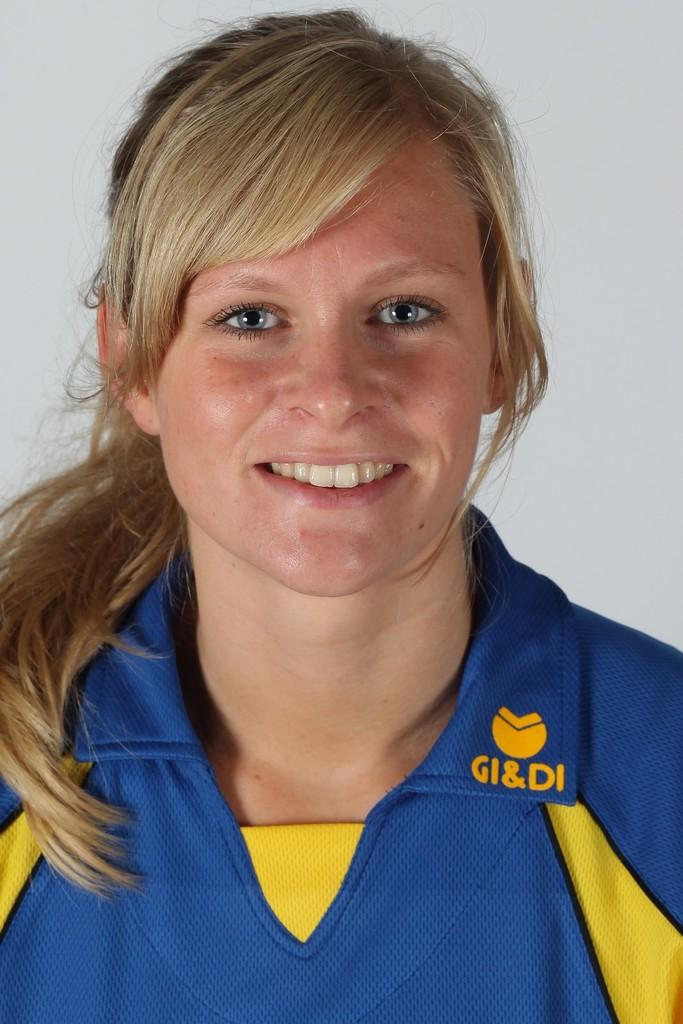Provide a one-sentence caption for the provided image. a woman wearing a shirt that says 'gi&di' on it. 